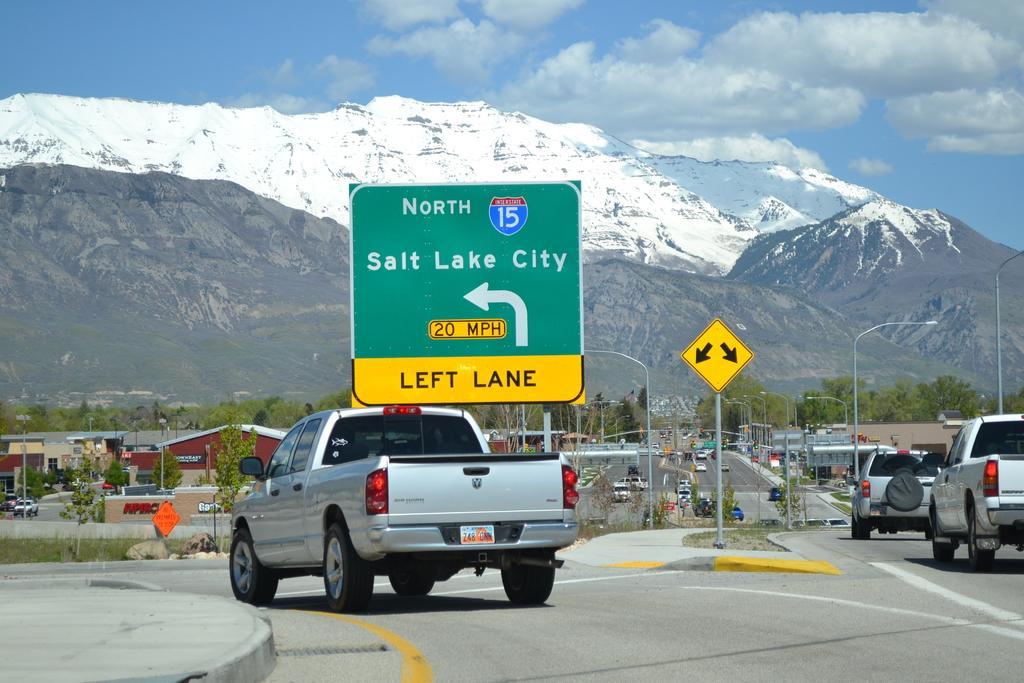Could you give a brief overview of what you see in this image? In this image we can see some vehicles which are moving on the road, we can see some signage boards, trees and some houses and in the background of the image there are some mountains and clear sky. 